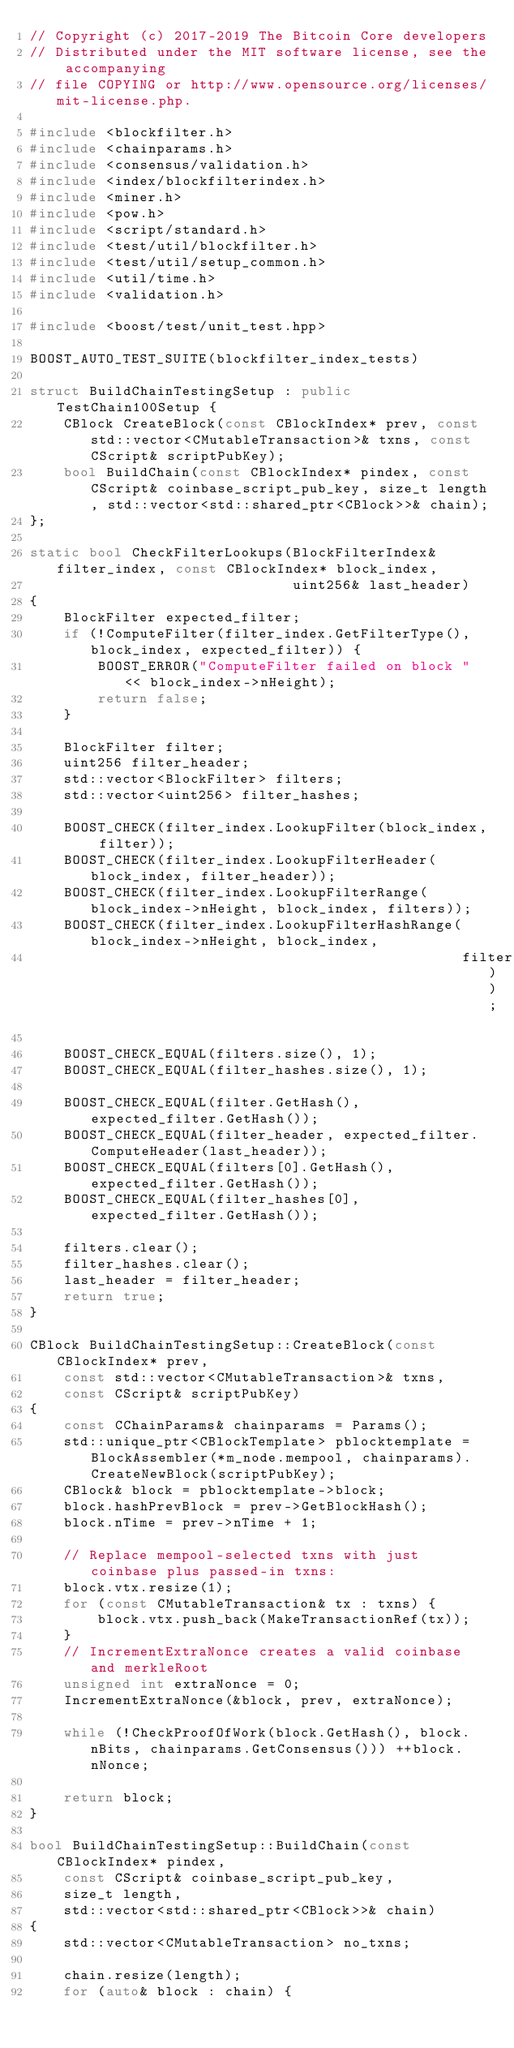<code> <loc_0><loc_0><loc_500><loc_500><_C++_>// Copyright (c) 2017-2019 The Bitcoin Core developers
// Distributed under the MIT software license, see the accompanying
// file COPYING or http://www.opensource.org/licenses/mit-license.php.

#include <blockfilter.h>
#include <chainparams.h>
#include <consensus/validation.h>
#include <index/blockfilterindex.h>
#include <miner.h>
#include <pow.h>
#include <script/standard.h>
#include <test/util/blockfilter.h>
#include <test/util/setup_common.h>
#include <util/time.h>
#include <validation.h>

#include <boost/test/unit_test.hpp>

BOOST_AUTO_TEST_SUITE(blockfilter_index_tests)

struct BuildChainTestingSetup : public TestChain100Setup {
    CBlock CreateBlock(const CBlockIndex* prev, const std::vector<CMutableTransaction>& txns, const CScript& scriptPubKey);
    bool BuildChain(const CBlockIndex* pindex, const CScript& coinbase_script_pub_key, size_t length, std::vector<std::shared_ptr<CBlock>>& chain);
};

static bool CheckFilterLookups(BlockFilterIndex& filter_index, const CBlockIndex* block_index,
                               uint256& last_header)
{
    BlockFilter expected_filter;
    if (!ComputeFilter(filter_index.GetFilterType(), block_index, expected_filter)) {
        BOOST_ERROR("ComputeFilter failed on block " << block_index->nHeight);
        return false;
    }

    BlockFilter filter;
    uint256 filter_header;
    std::vector<BlockFilter> filters;
    std::vector<uint256> filter_hashes;

    BOOST_CHECK(filter_index.LookupFilter(block_index, filter));
    BOOST_CHECK(filter_index.LookupFilterHeader(block_index, filter_header));
    BOOST_CHECK(filter_index.LookupFilterRange(block_index->nHeight, block_index, filters));
    BOOST_CHECK(filter_index.LookupFilterHashRange(block_index->nHeight, block_index,
                                                   filter_hashes));

    BOOST_CHECK_EQUAL(filters.size(), 1);
    BOOST_CHECK_EQUAL(filter_hashes.size(), 1);

    BOOST_CHECK_EQUAL(filter.GetHash(), expected_filter.GetHash());
    BOOST_CHECK_EQUAL(filter_header, expected_filter.ComputeHeader(last_header));
    BOOST_CHECK_EQUAL(filters[0].GetHash(), expected_filter.GetHash());
    BOOST_CHECK_EQUAL(filter_hashes[0], expected_filter.GetHash());

    filters.clear();
    filter_hashes.clear();
    last_header = filter_header;
    return true;
}

CBlock BuildChainTestingSetup::CreateBlock(const CBlockIndex* prev,
    const std::vector<CMutableTransaction>& txns,
    const CScript& scriptPubKey)
{
    const CChainParams& chainparams = Params();
    std::unique_ptr<CBlockTemplate> pblocktemplate = BlockAssembler(*m_node.mempool, chainparams).CreateNewBlock(scriptPubKey);
    CBlock& block = pblocktemplate->block;
    block.hashPrevBlock = prev->GetBlockHash();
    block.nTime = prev->nTime + 1;

    // Replace mempool-selected txns with just coinbase plus passed-in txns:
    block.vtx.resize(1);
    for (const CMutableTransaction& tx : txns) {
        block.vtx.push_back(MakeTransactionRef(tx));
    }
    // IncrementExtraNonce creates a valid coinbase and merkleRoot
    unsigned int extraNonce = 0;
    IncrementExtraNonce(&block, prev, extraNonce);

    while (!CheckProofOfWork(block.GetHash(), block.nBits, chainparams.GetConsensus())) ++block.nNonce;

    return block;
}

bool BuildChainTestingSetup::BuildChain(const CBlockIndex* pindex,
    const CScript& coinbase_script_pub_key,
    size_t length,
    std::vector<std::shared_ptr<CBlock>>& chain)
{
    std::vector<CMutableTransaction> no_txns;

    chain.resize(length);
    for (auto& block : chain) {</code> 